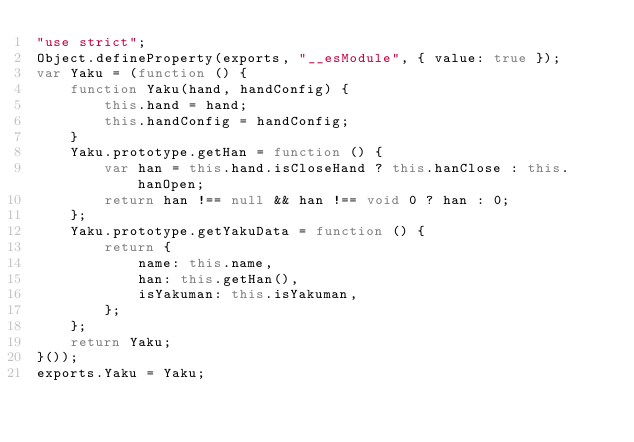<code> <loc_0><loc_0><loc_500><loc_500><_JavaScript_>"use strict";
Object.defineProperty(exports, "__esModule", { value: true });
var Yaku = (function () {
    function Yaku(hand, handConfig) {
        this.hand = hand;
        this.handConfig = handConfig;
    }
    Yaku.prototype.getHan = function () {
        var han = this.hand.isCloseHand ? this.hanClose : this.hanOpen;
        return han !== null && han !== void 0 ? han : 0;
    };
    Yaku.prototype.getYakuData = function () {
        return {
            name: this.name,
            han: this.getHan(),
            isYakuman: this.isYakuman,
        };
    };
    return Yaku;
}());
exports.Yaku = Yaku;
</code> 